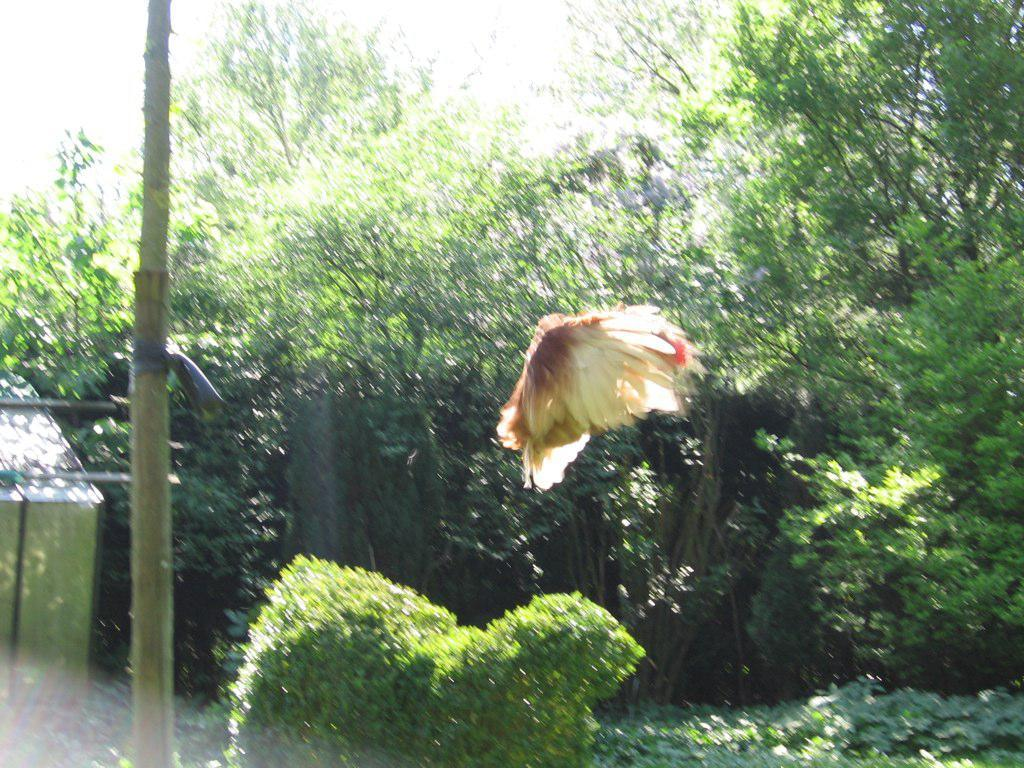What type of animal is in the image? There is a bird in the image. Can you describe the bird's appearance? The bird has brown and cream colors. What can be seen in the background of the image? There are plants, trees, a wooden pole, and the sky visible in the background of the image. What color are the trees in the background? The trees have green colors. What color is the sky in the background? The sky is visible in the background of the image and has a white color. What suggestion does the bird make to the trees in the image? There is no suggestion made by the bird to the trees in the image, as birds do not communicate with trees in this manner. 